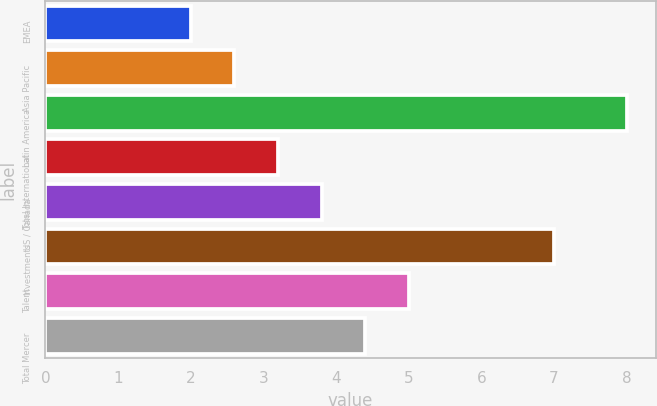Convert chart. <chart><loc_0><loc_0><loc_500><loc_500><bar_chart><fcel>EMEA<fcel>Asia Pacific<fcel>Latin America<fcel>Total International<fcel>US / Canada<fcel>Investments<fcel>Talent<fcel>Total Mercer<nl><fcel>2<fcel>2.6<fcel>8<fcel>3.2<fcel>3.8<fcel>7<fcel>5<fcel>4.4<nl></chart> 